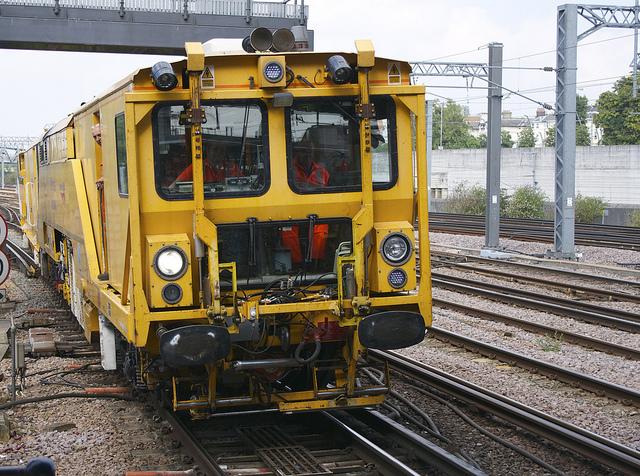What color is the train?
Concise answer only. Yellow. Why are there tracks on the ground?
Answer briefly. For train. Is the train on the street?
Short answer required. No. 